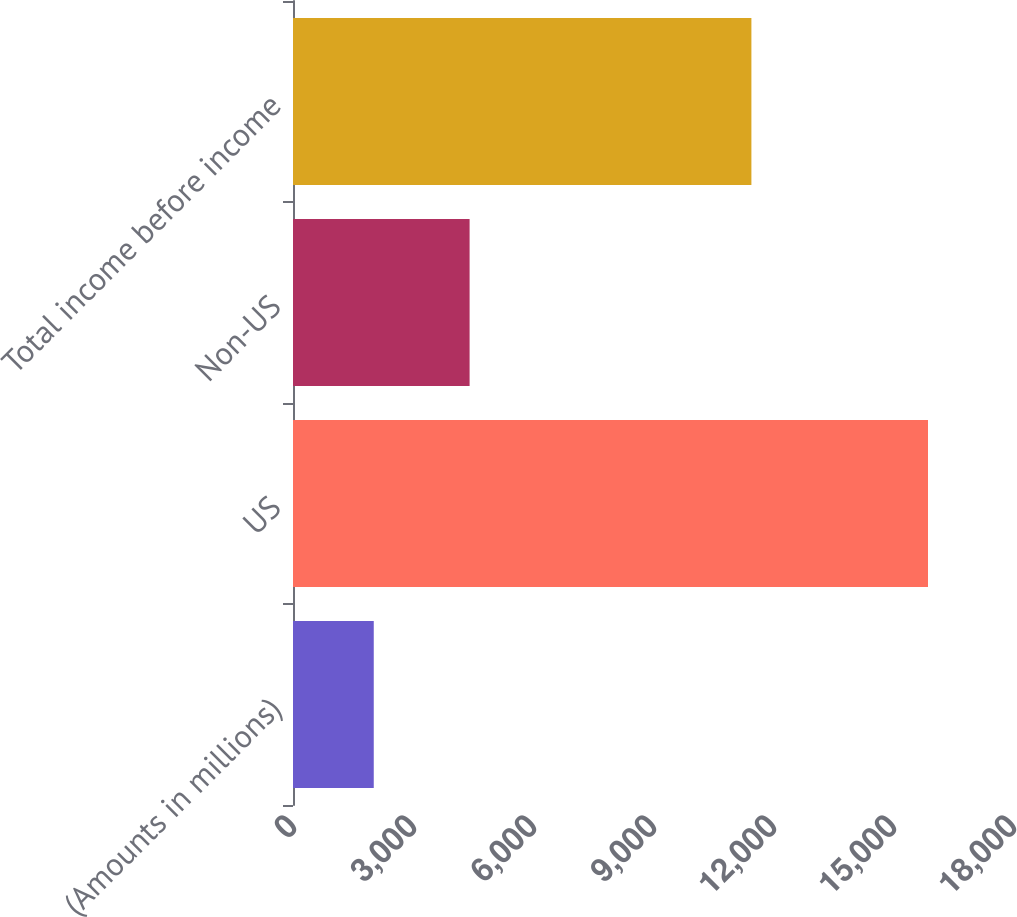Convert chart to OTSL. <chart><loc_0><loc_0><loc_500><loc_500><bar_chart><fcel>(Amounts in millions)<fcel>US<fcel>Non-US<fcel>Total income before income<nl><fcel>2019<fcel>15875<fcel>4415<fcel>11460<nl></chart> 